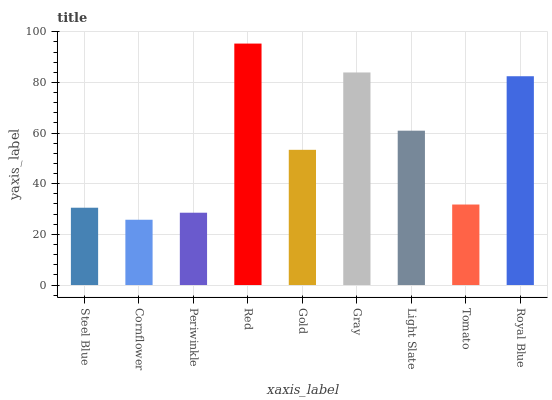Is Cornflower the minimum?
Answer yes or no. Yes. Is Red the maximum?
Answer yes or no. Yes. Is Periwinkle the minimum?
Answer yes or no. No. Is Periwinkle the maximum?
Answer yes or no. No. Is Periwinkle greater than Cornflower?
Answer yes or no. Yes. Is Cornflower less than Periwinkle?
Answer yes or no. Yes. Is Cornflower greater than Periwinkle?
Answer yes or no. No. Is Periwinkle less than Cornflower?
Answer yes or no. No. Is Gold the high median?
Answer yes or no. Yes. Is Gold the low median?
Answer yes or no. Yes. Is Light Slate the high median?
Answer yes or no. No. Is Royal Blue the low median?
Answer yes or no. No. 